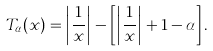<formula> <loc_0><loc_0><loc_500><loc_500>T _ { \alpha } ( x ) = \left | \frac { 1 } { x } \right | - \left [ \left | \frac { 1 } { x } \right | + 1 - \alpha \right ] .</formula> 